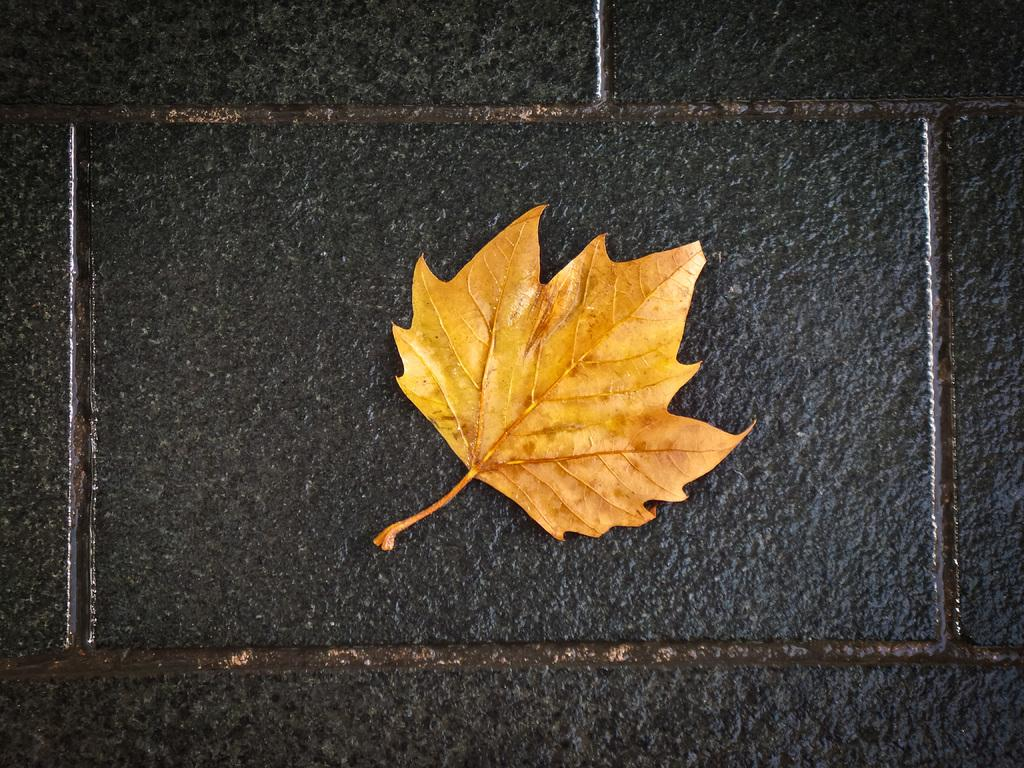What is the color of the leaf in the image? The leaf in the image is yellow. What is the color of the surface on which the leaf is placed? The surface is black. How many minutes does it take for the waves to reach the shore in the image? There are no waves present in the image, so it is not possible to determine how long it takes for them to reach the shore. 